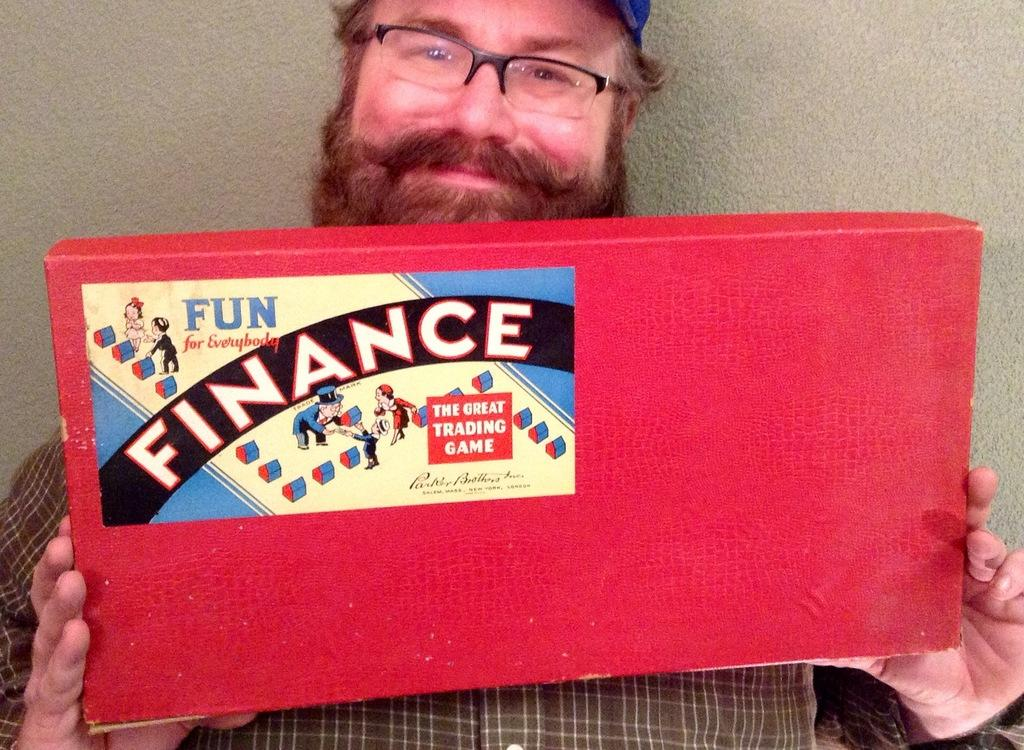What is the main subject of the picture? The main subject of the picture is a person. Can you describe the person's appearance? The person is wearing spectacles. What is the person holding in the picture? The person is holding a red color box. What type of rail can be seen in the picture? There is no rail present in the picture; it features a person wearing spectacles and holding a red color box. What kind of action is the person taking in the picture? The provided facts do not mention any specific action being taken by the person in the image. 